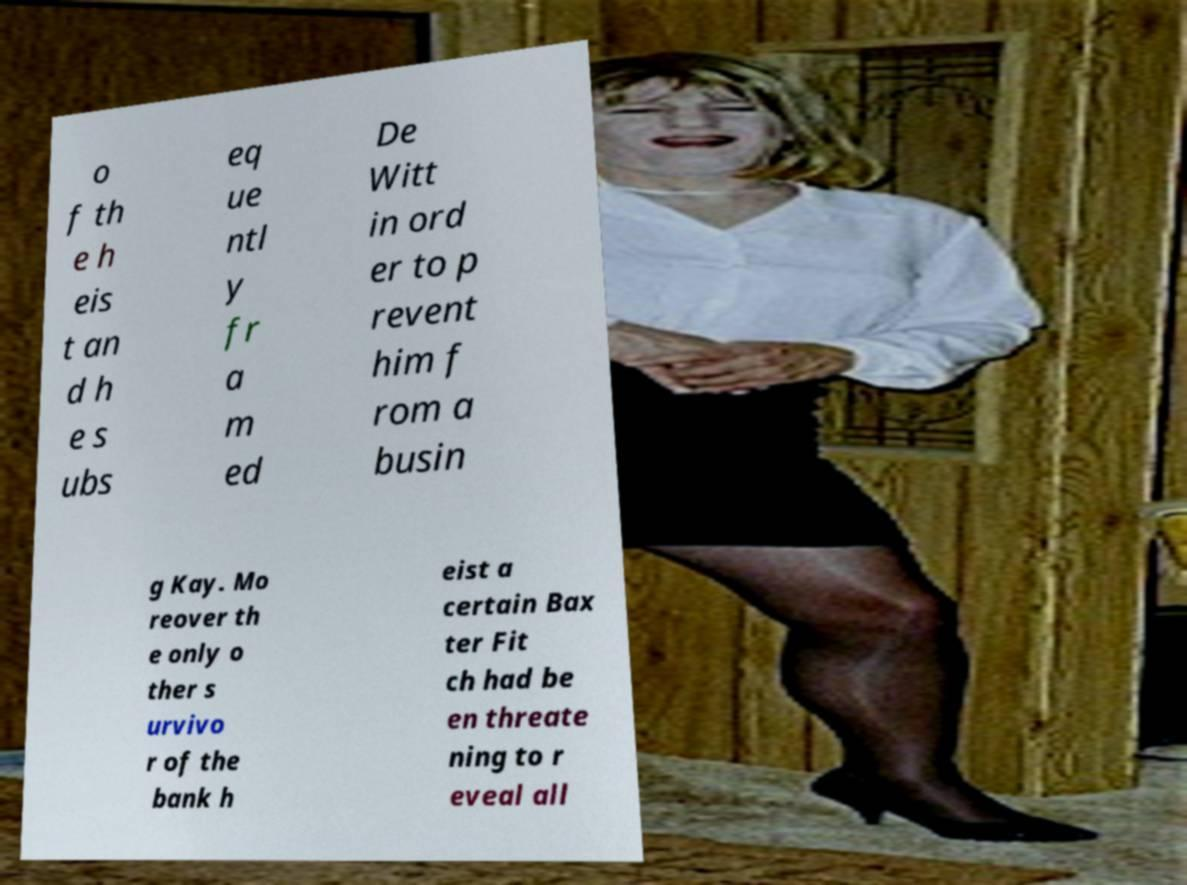I need the written content from this picture converted into text. Can you do that? o f th e h eis t an d h e s ubs eq ue ntl y fr a m ed De Witt in ord er to p revent him f rom a busin g Kay. Mo reover th e only o ther s urvivo r of the bank h eist a certain Bax ter Fit ch had be en threate ning to r eveal all 